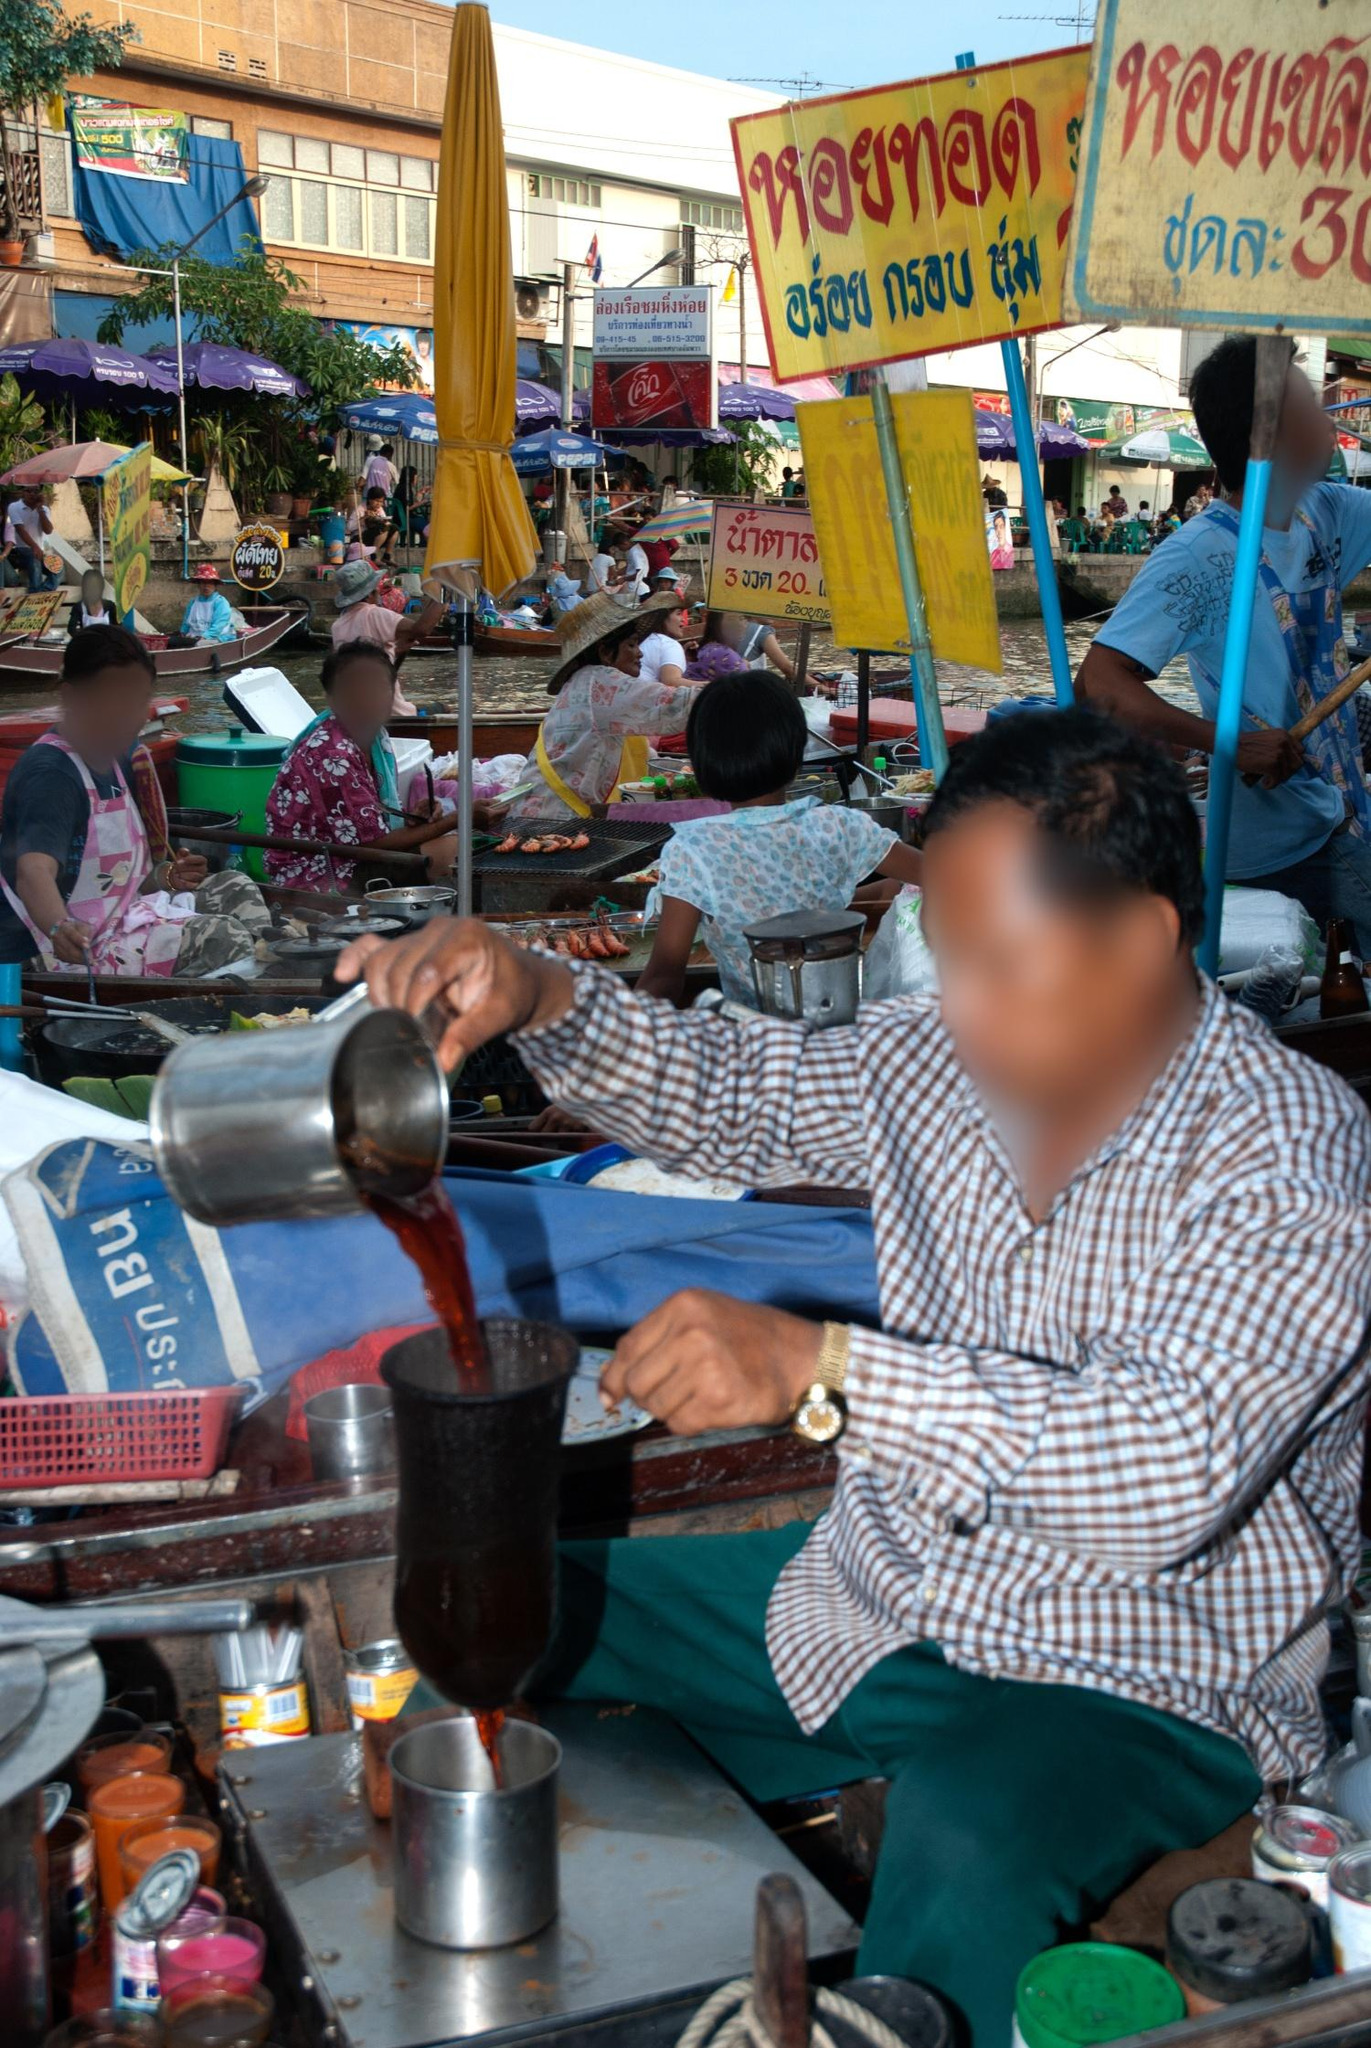What stands out to you in this image? One striking feature of this image is the vibrant and lively nature of the floating market depicted. The array of vivid colors from the bottles, containers, and signs draws the eye, while the bustling background of boats and vendors captures the essence of daily market life in Thailand. The man in the foreground, concentrating as he pours a red liquid, adds a focal point that emphasizes the busy yet meticulous atmosphere of the market. 